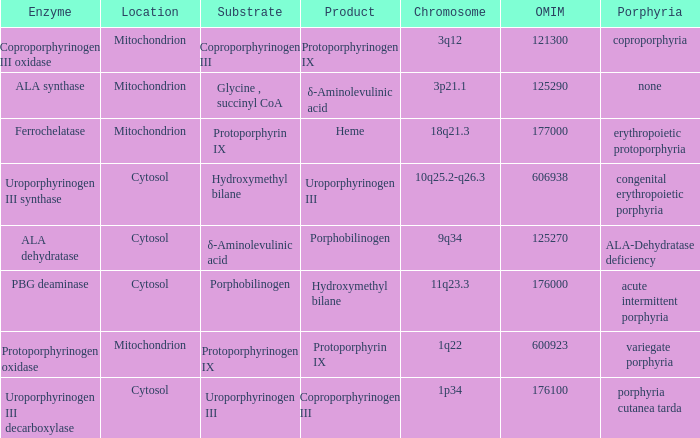Can you give me this table as a dict? {'header': ['Enzyme', 'Location', 'Substrate', 'Product', 'Chromosome', 'OMIM', 'Porphyria'], 'rows': [['Coproporphyrinogen III oxidase', 'Mitochondrion', 'Coproporphyrinogen III', 'Protoporphyrinogen IX', '3q12', '121300', 'coproporphyria'], ['ALA synthase', 'Mitochondrion', 'Glycine , succinyl CoA', 'δ-Aminolevulinic acid', '3p21.1', '125290', 'none'], ['Ferrochelatase', 'Mitochondrion', 'Protoporphyrin IX', 'Heme', '18q21.3', '177000', 'erythropoietic protoporphyria'], ['Uroporphyrinogen III synthase', 'Cytosol', 'Hydroxymethyl bilane', 'Uroporphyrinogen III', '10q25.2-q26.3', '606938', 'congenital erythropoietic porphyria'], ['ALA dehydratase', 'Cytosol', 'δ-Aminolevulinic acid', 'Porphobilinogen', '9q34', '125270', 'ALA-Dehydratase deficiency'], ['PBG deaminase', 'Cytosol', 'Porphobilinogen', 'Hydroxymethyl bilane', '11q23.3', '176000', 'acute intermittent porphyria'], ['Protoporphyrinogen oxidase', 'Mitochondrion', 'Protoporphyrinogen IX', 'Protoporphyrin IX', '1q22', '600923', 'variegate porphyria'], ['Uroporphyrinogen III decarboxylase', 'Cytosol', 'Uroporphyrinogen III', 'Coproporphyrinogen III', '1p34', '176100', 'porphyria cutanea tarda']]} Which substrate has an OMIM of 176000? Porphobilinogen. 